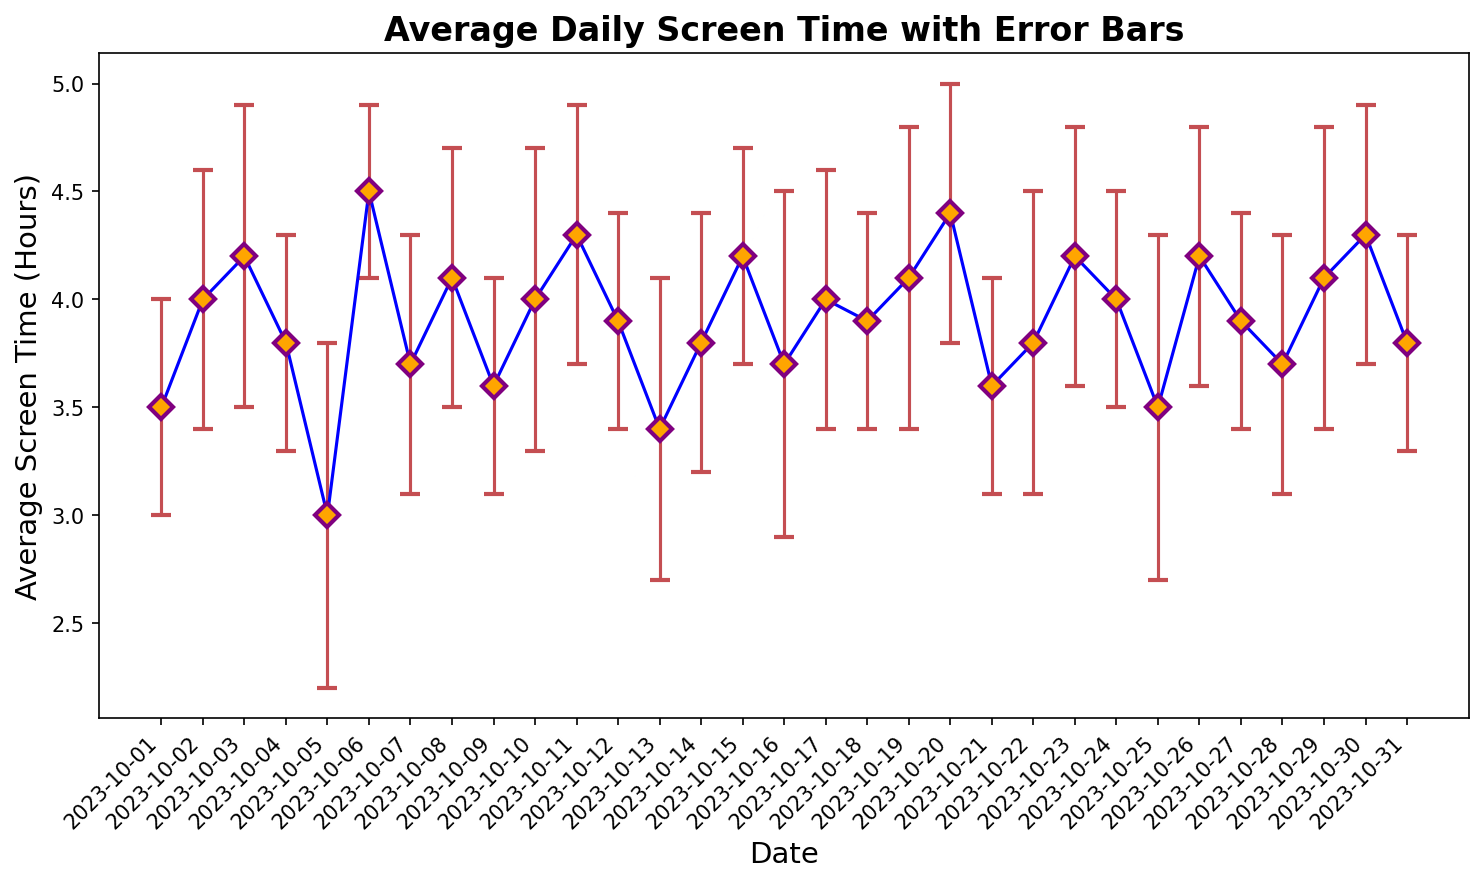What's the average daily screen time across the entire month? Add up all the average screen time values and divide by the number of days in the month. The total sum is 3.5 + 4.0 + 4.2 + 3.8 + 3.0 + 4.5 + 3.7 + 4.1 + 3.6 + 4.0 + 4.3 + 3.9 + 3.4 + 3.8 + 4.2 + 3.7 + 4.0 + 3.9 + 4.1 + 4.4 + 3.6 + 3.8 + 4.2 + 4.0 + 3.5 + 4.2 + 3.9 + 3.7 + 4.1 + 4.3 + 3.8 = 122.5 hours. Dividing by 31 days gives an average of 3.95 hours.
Answer: 3.95 hours Which day had the highest average daily screen time? From the plot, the day with the highest screen time is clearly visible. On October 6th, the average screen time was 4.5 hours, which is the highest.
Answer: October 6th What is the range of average daily screen time over the month? The range is calculated as the difference between the maximum and minimum average screen time values. The maximum value is 4.5 (October 6th) and the minimum value is 3.0 (October 5th). The range is 4.5 - 3.0 = 1.5 hours.
Answer: 1.5 hours On which dates does the average screen time fall below 3.5 hours? From the figure, we can spot the days where the screen time is below 3.5 hours. These dates are October 5th (3.0 hours) and October 13th (3.4 hours).
Answer: October 5th and October 13th Are there more days with an average screen time above or below 4 hours? First, count the number of days with screen time above 4 hours and those below it. Days with screen time above 4 hours are: October 2nd, 3rd, 6th, 8th, 11th, 15th, 19th, 20th, 23rd, 26th, 29th, and 30th (12 days). Days below 4 hours: October 1st, 4th, 5th, 7th, 9th, 10th, 12th, 13th, 14th, 16th, 17th, 18th, 21st, 22nd, 24th, 25th, 27th, 28th, and 31st (19 days).
Answer: Below 4 hours Which day showed the highest discrepancy due to physical strain or fatigue? The discrepancy is represented by the error bars on the plot. The largest error bar corresponds to October 5th with a standard deviation of 0.8 hours.
Answer: October 5th What is the combined average screen time for weekends (Saturdays and Sundays) in October? Calculate the average screen time for all Saturdays and Sundays, then find their average. Weekends: 7th (3.7 hours), 8th (4.1 hours), 14th (3.8 hours), 15th (4.2 hours), 21st (3.6 hours), 22nd (3.8 hours), 28th (3.7 hours), 29th (4.1 hours). Summing these gives 31.0 hours, dividing by 8 gives 3.875 hours.
Answer: 3.875 hours 